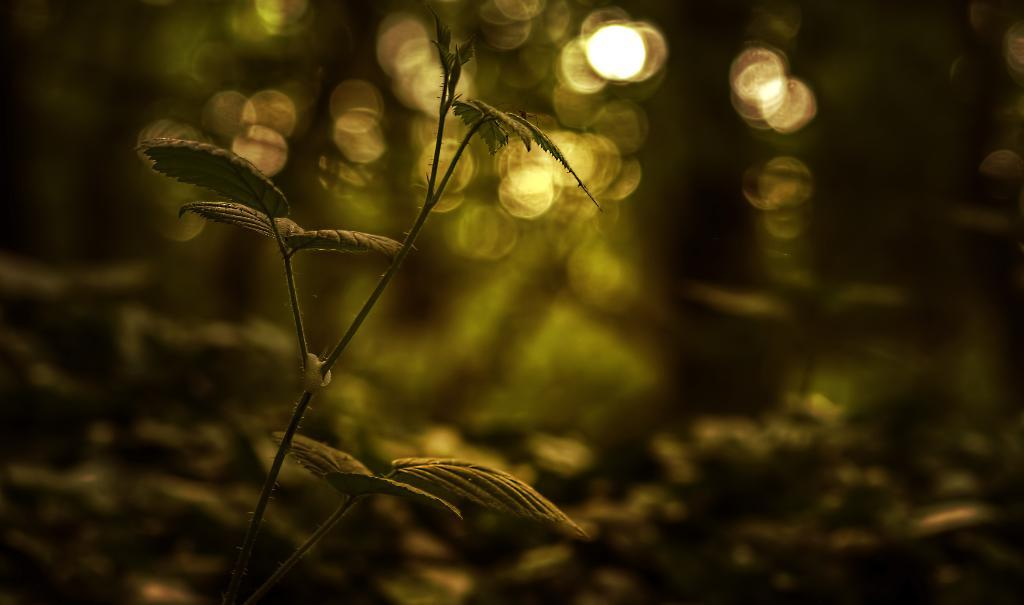What is the main subject of the picture? The main subject of the picture is a small plant sampling. Are there any other plants visible in the image? Yes, there are other plants visible behind the small plant sampling, but they are not clearly visible. How much money is being used to water the plants in the image? There is no money present in the image, and the plants are not being watered. 